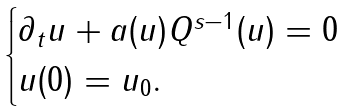Convert formula to latex. <formula><loc_0><loc_0><loc_500><loc_500>\begin{cases} \partial _ { t } u + a ( u ) Q ^ { s - 1 } ( u ) = 0 \\ u ( 0 ) = u _ { 0 } . \end{cases}</formula> 